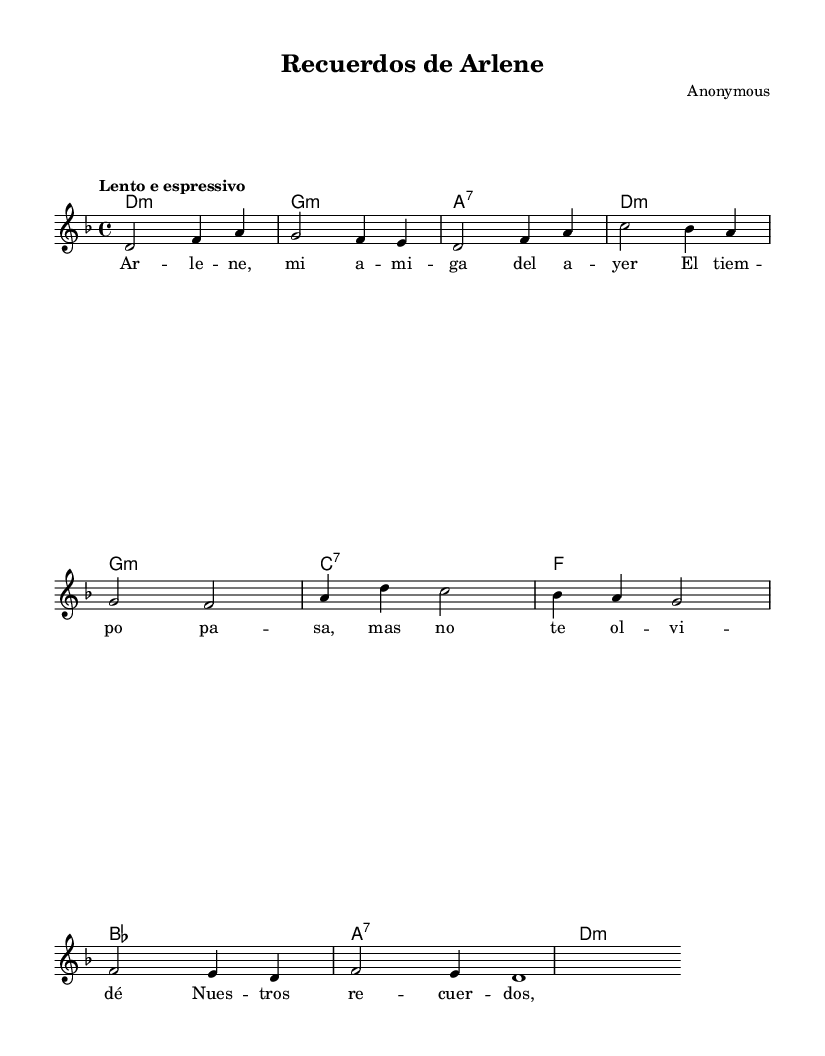What is the key signature of this music? The key signature is indicated at the beginning of the score, showing two flats, which corresponds to the key of D minor.
Answer: D minor What is the time signature of this music? The time signature can be found at the beginning of the staff, marked as 4/4, which indicates that there are four beats in each measure.
Answer: 4/4 What is the tempo marking for this piece? The tempo is described as "Lento e espressivo" at the start of the score, suggesting a slow and expressive playing style.
Answer: Lento e espressivo How many measures are there in the melody? By counting the measures in the melody section, we see that there are a total of 8 measures represented.
Answer: 8 What type of chord is the first chord in the harmony? The first chord symbol shown is "d:m", which indicates that it is a D minor chord.
Answer: D minor What recurring theme is present in the lyrics? The lyrics reflect a sense of nostalgia and enduring connection, as illustrated by phrases related to memories and time.
Answer: Nostalgia How does the structure of the bolero influence its sentimental nature? The bolero's characteristic slow tempo and repetitive melodic structures enhance its emotional expression, which aligns with the themes of memory and longing in the song.
Answer: Emotional expression 